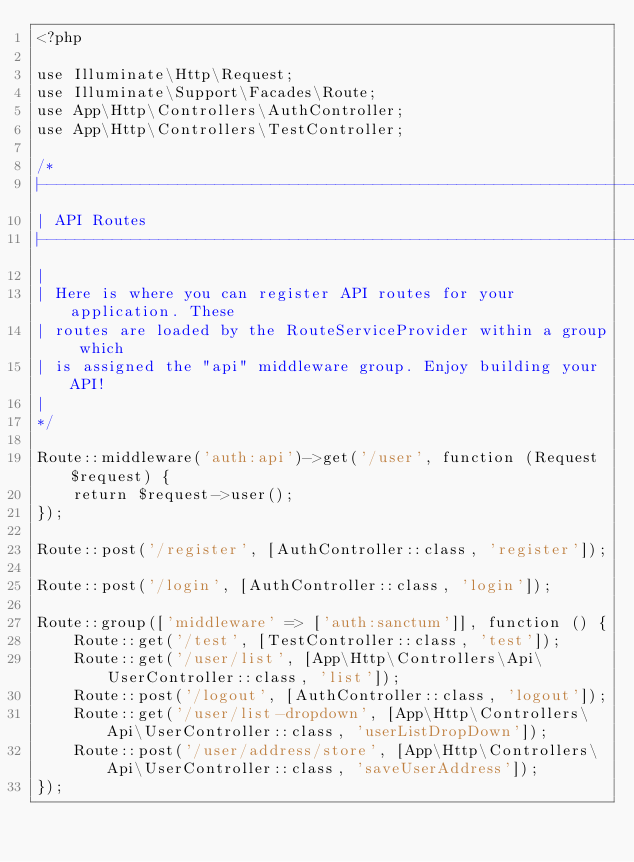Convert code to text. <code><loc_0><loc_0><loc_500><loc_500><_PHP_><?php

use Illuminate\Http\Request;
use Illuminate\Support\Facades\Route;
use App\Http\Controllers\AuthController;
use App\Http\Controllers\TestController;

/*
|--------------------------------------------------------------------------
| API Routes
|--------------------------------------------------------------------------
|
| Here is where you can register API routes for your application. These
| routes are loaded by the RouteServiceProvider within a group which
| is assigned the "api" middleware group. Enjoy building your API!
|
*/

Route::middleware('auth:api')->get('/user', function (Request $request) {
    return $request->user();
});

Route::post('/register', [AuthController::class, 'register']);

Route::post('/login', [AuthController::class, 'login']);

Route::group(['middleware' => ['auth:sanctum']], function () {
    Route::get('/test', [TestController::class, 'test']);
    Route::get('/user/list', [App\Http\Controllers\Api\UserController::class, 'list']);
    Route::post('/logout', [AuthController::class, 'logout']);
    Route::get('/user/list-dropdown', [App\Http\Controllers\Api\UserController::class, 'userListDropDown']);
    Route::post('/user/address/store', [App\Http\Controllers\Api\UserController::class, 'saveUserAddress']);
});
</code> 